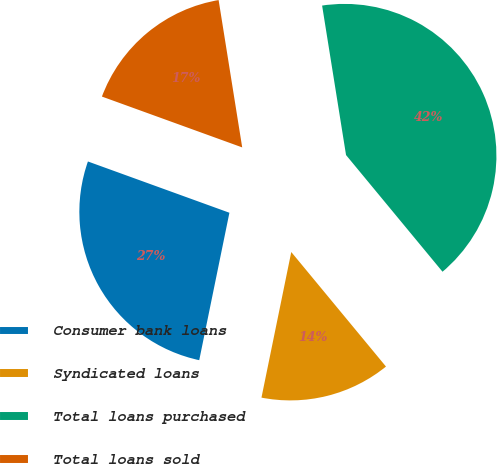Convert chart. <chart><loc_0><loc_0><loc_500><loc_500><pie_chart><fcel>Consumer bank loans<fcel>Syndicated loans<fcel>Total loans purchased<fcel>Total loans sold<nl><fcel>27.32%<fcel>14.21%<fcel>41.53%<fcel>16.94%<nl></chart> 